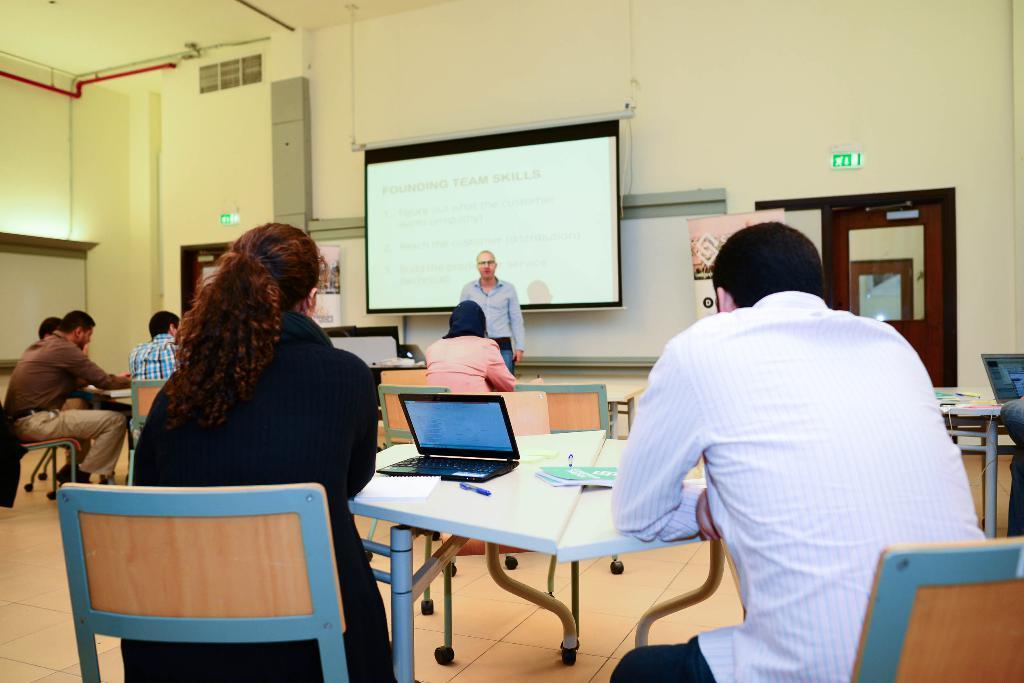Describe this image in one or two sentences. There are many person sitting on chairs. There are tables. On the table there is a laptop, pen and paper. In the background a person is standing. There is a wall. On the wall there is a screen. There is a door and sign board on the wall. 